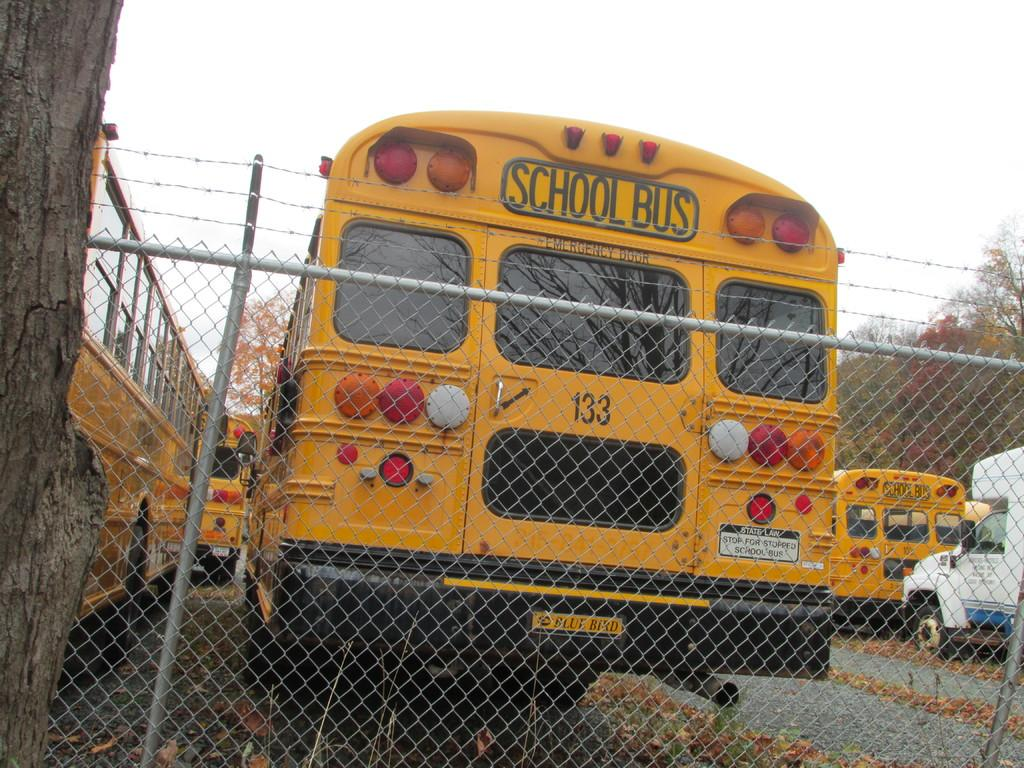<image>
Describe the image concisely. A yellow school bus with blue bird logo on the bottom and number 133 on the back. 